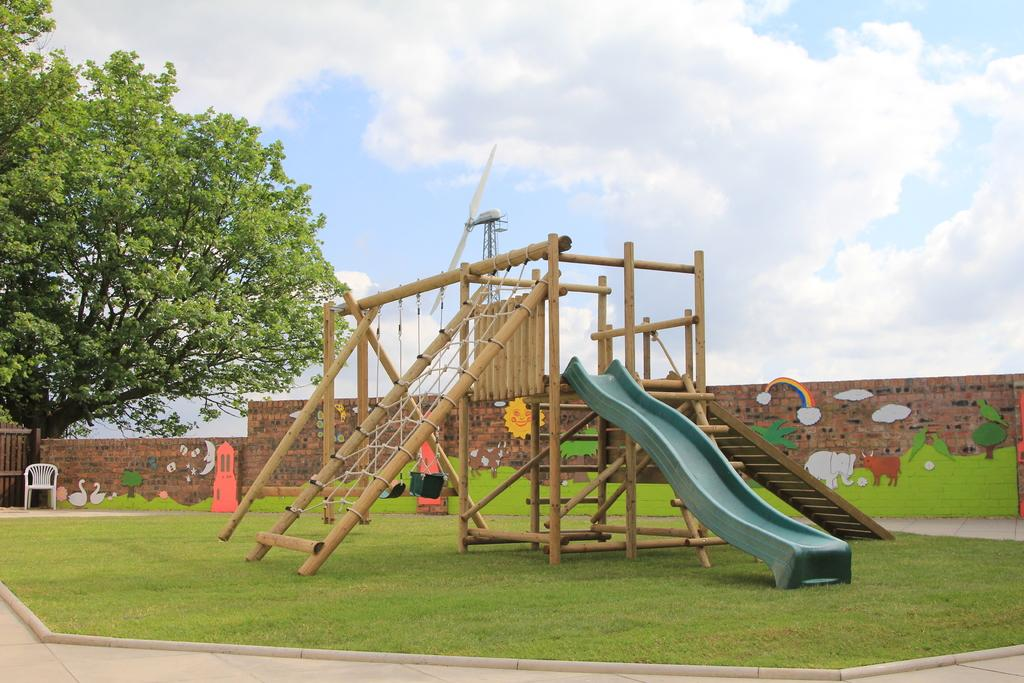What type of playground equipment is present in the image? There is a slide in the image. What other objects can be seen in the image? There are ropes and wooden poles visible in the image. What is located behind the slide in the image? There is a chair behind the slide in the image. What can be seen in the background of the image? There are trees, a wall, and the sky visible in the background of the image. What is on the wall in the background? There are paintings on the wall in the background. How many brothers are playing on the slide in the image? There is no mention of brothers or anyone playing on the slide in the image. Is the area around the slide quiet in the image? The image does not provide any information about the noise level in the area around the slide. 